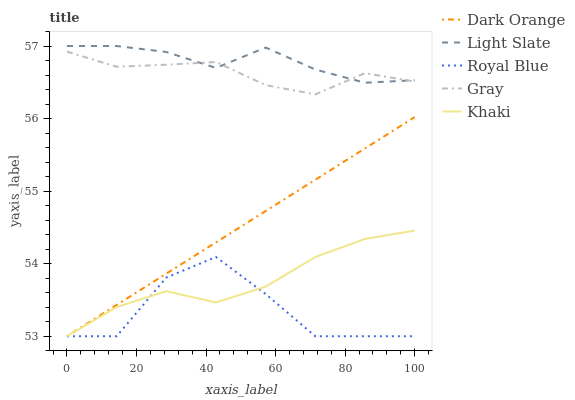Does Royal Blue have the minimum area under the curve?
Answer yes or no. Yes. Does Light Slate have the maximum area under the curve?
Answer yes or no. Yes. Does Dark Orange have the minimum area under the curve?
Answer yes or no. No. Does Dark Orange have the maximum area under the curve?
Answer yes or no. No. Is Dark Orange the smoothest?
Answer yes or no. Yes. Is Royal Blue the roughest?
Answer yes or no. Yes. Is Gray the smoothest?
Answer yes or no. No. Is Gray the roughest?
Answer yes or no. No. Does Dark Orange have the lowest value?
Answer yes or no. Yes. Does Gray have the lowest value?
Answer yes or no. No. Does Light Slate have the highest value?
Answer yes or no. Yes. Does Dark Orange have the highest value?
Answer yes or no. No. Is Dark Orange less than Light Slate?
Answer yes or no. Yes. Is Gray greater than Khaki?
Answer yes or no. Yes. Does Khaki intersect Dark Orange?
Answer yes or no. Yes. Is Khaki less than Dark Orange?
Answer yes or no. No. Is Khaki greater than Dark Orange?
Answer yes or no. No. Does Dark Orange intersect Light Slate?
Answer yes or no. No. 